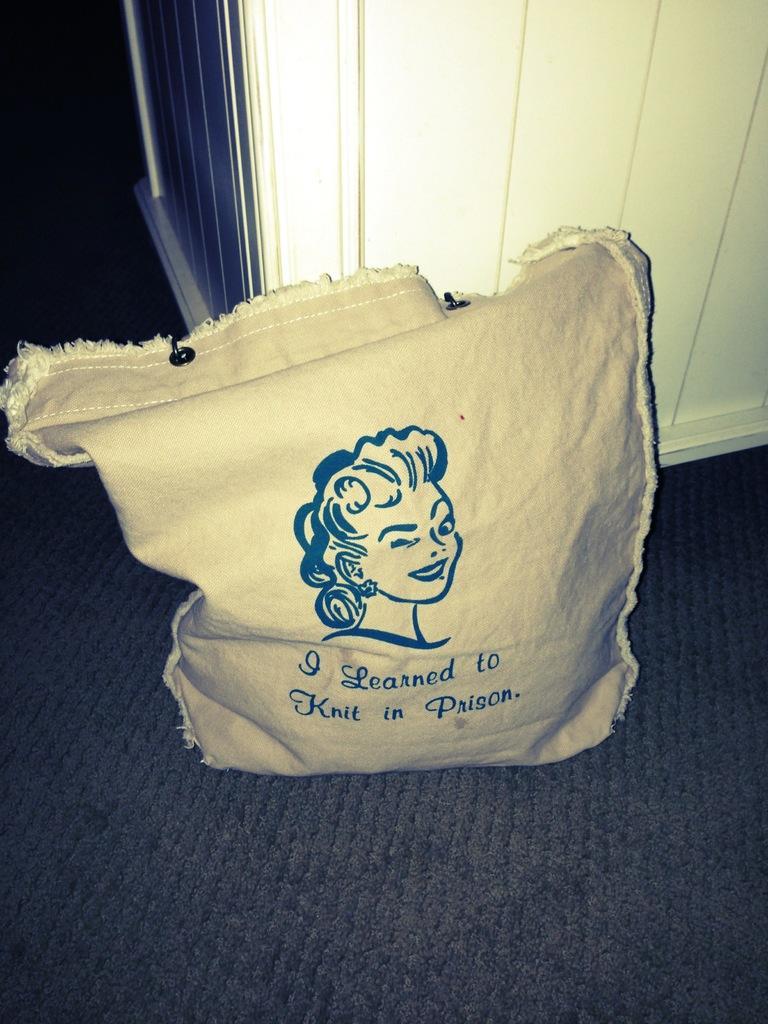Describe this image in one or two sentences. In this image I can see a bag is placed on the floor. On the bag, I can see some text and a painting of a person. At the back of this bag there is a white color object which seems to be a table. 